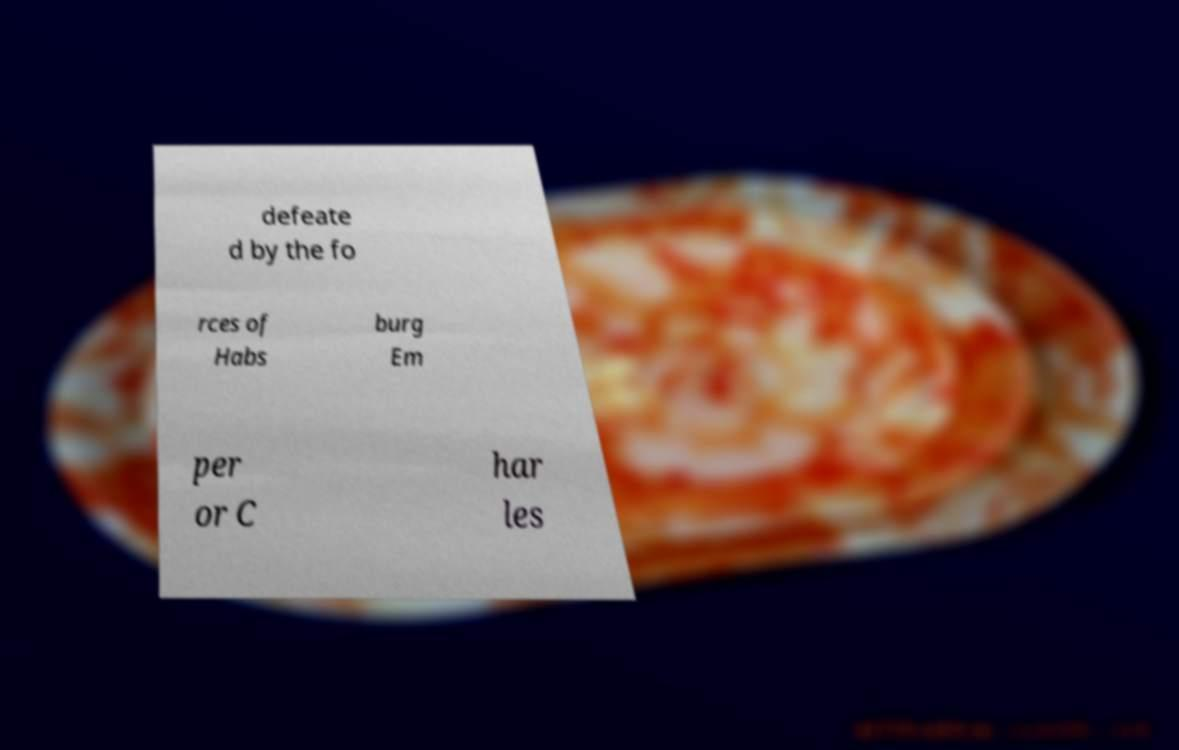Could you assist in decoding the text presented in this image and type it out clearly? defeate d by the fo rces of Habs burg Em per or C har les 